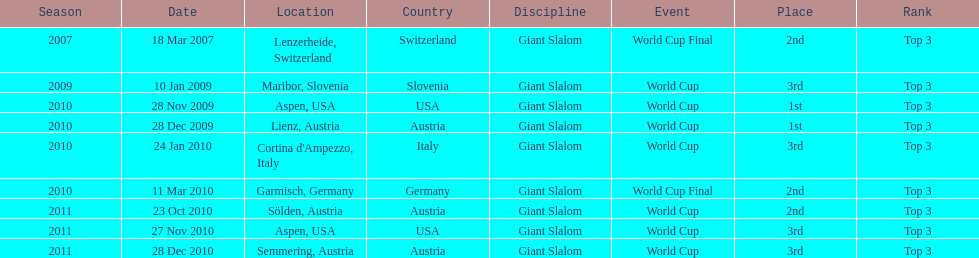What is the total number of her 2nd place finishes on the list? 3. 